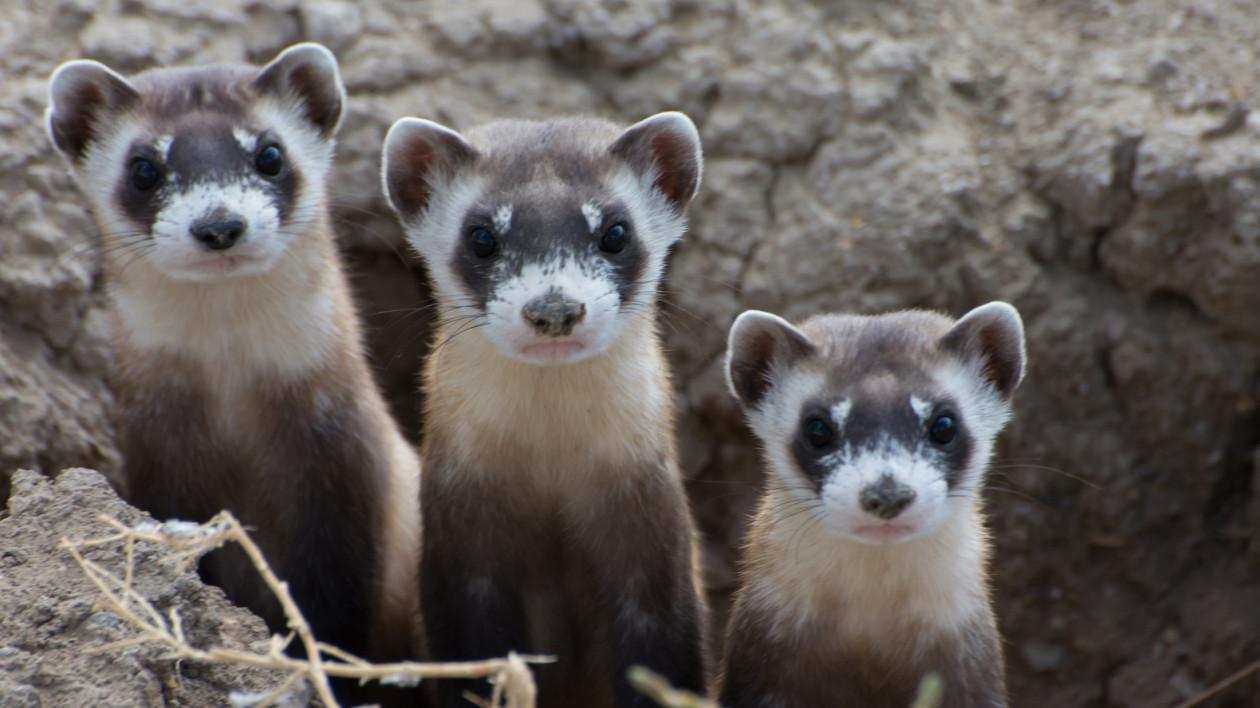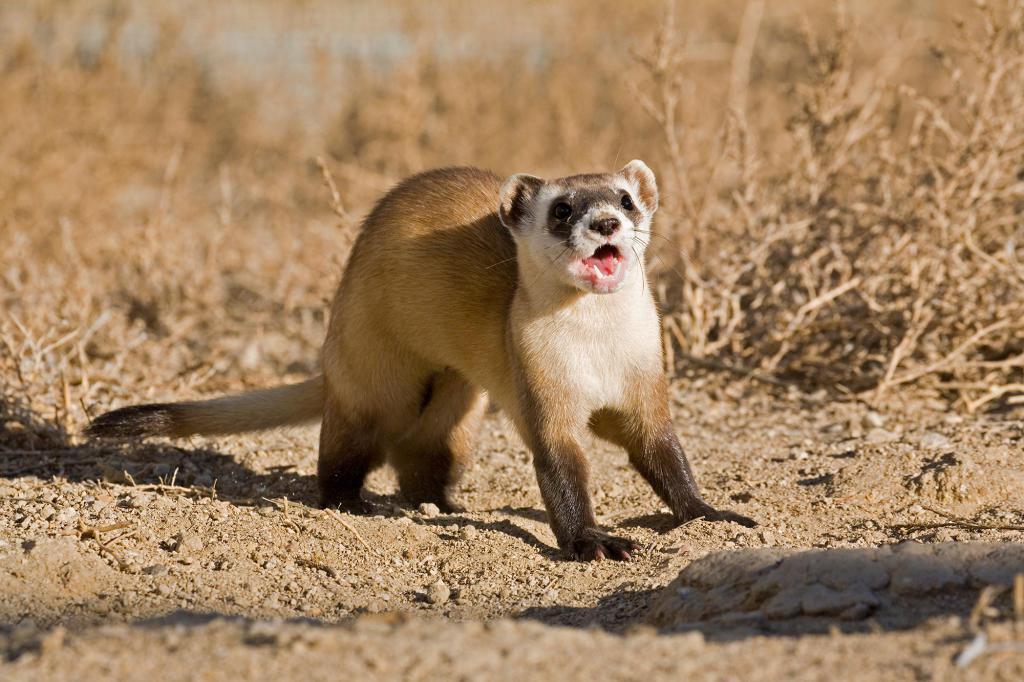The first image is the image on the left, the second image is the image on the right. Considering the images on both sides, is "There are two animals in total." valid? Answer yes or no. No. The first image is the image on the left, the second image is the image on the right. Considering the images on both sides, is "An image shows exactly one ferret partly emerged from a hole in the ground, with no manmade material visible." valid? Answer yes or no. No. 